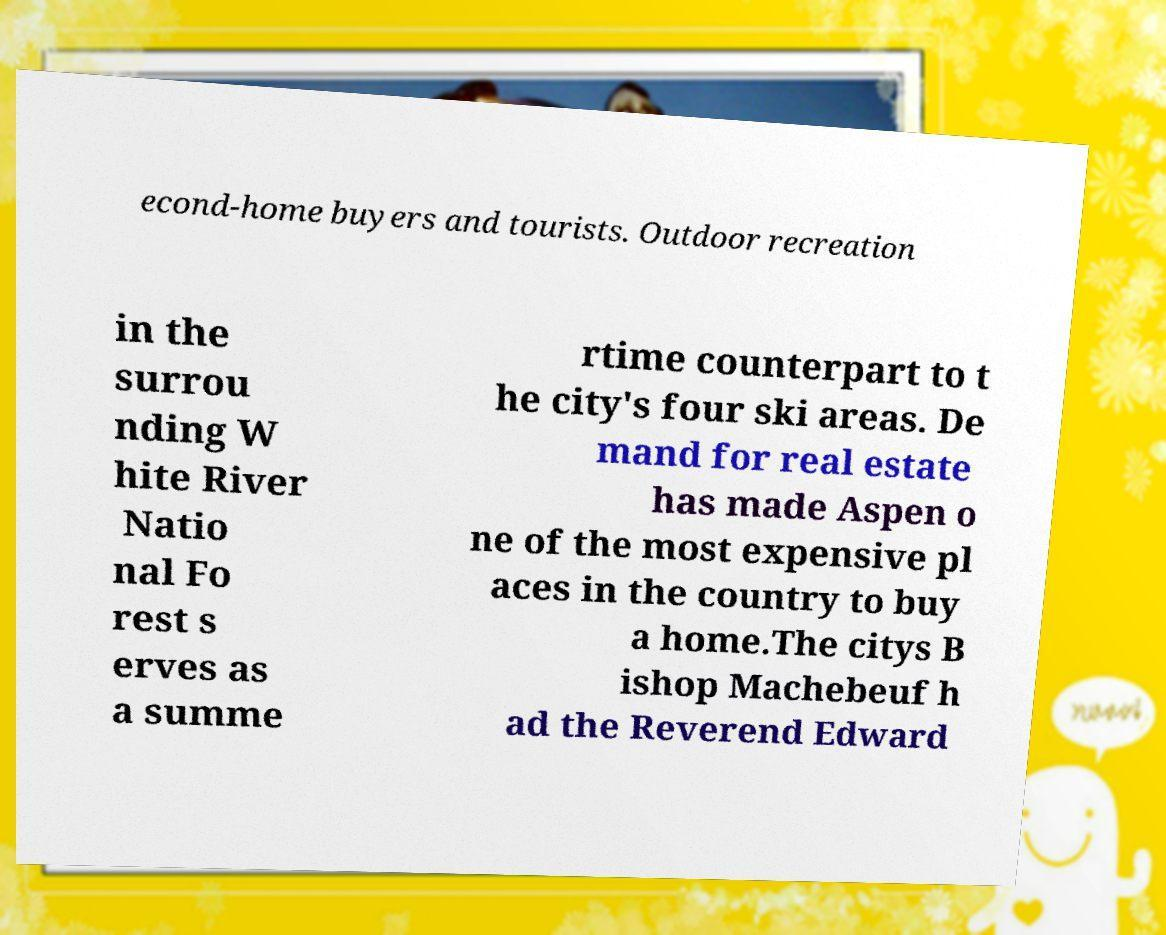For documentation purposes, I need the text within this image transcribed. Could you provide that? econd-home buyers and tourists. Outdoor recreation in the surrou nding W hite River Natio nal Fo rest s erves as a summe rtime counterpart to t he city's four ski areas. De mand for real estate has made Aspen o ne of the most expensive pl aces in the country to buy a home.The citys B ishop Machebeuf h ad the Reverend Edward 